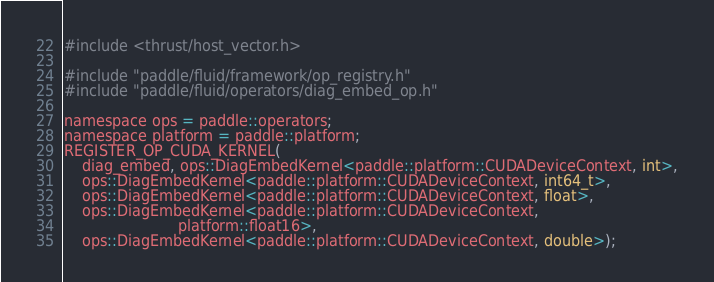<code> <loc_0><loc_0><loc_500><loc_500><_Cuda_>#include <thrust/host_vector.h>

#include "paddle/fluid/framework/op_registry.h"
#include "paddle/fluid/operators/diag_embed_op.h"

namespace ops = paddle::operators;
namespace platform = paddle::platform;
REGISTER_OP_CUDA_KERNEL(
    diag_embed, ops::DiagEmbedKernel<paddle::platform::CUDADeviceContext, int>,
    ops::DiagEmbedKernel<paddle::platform::CUDADeviceContext, int64_t>,
    ops::DiagEmbedKernel<paddle::platform::CUDADeviceContext, float>,
    ops::DiagEmbedKernel<paddle::platform::CUDADeviceContext,
                         platform::float16>,
    ops::DiagEmbedKernel<paddle::platform::CUDADeviceContext, double>);
</code> 